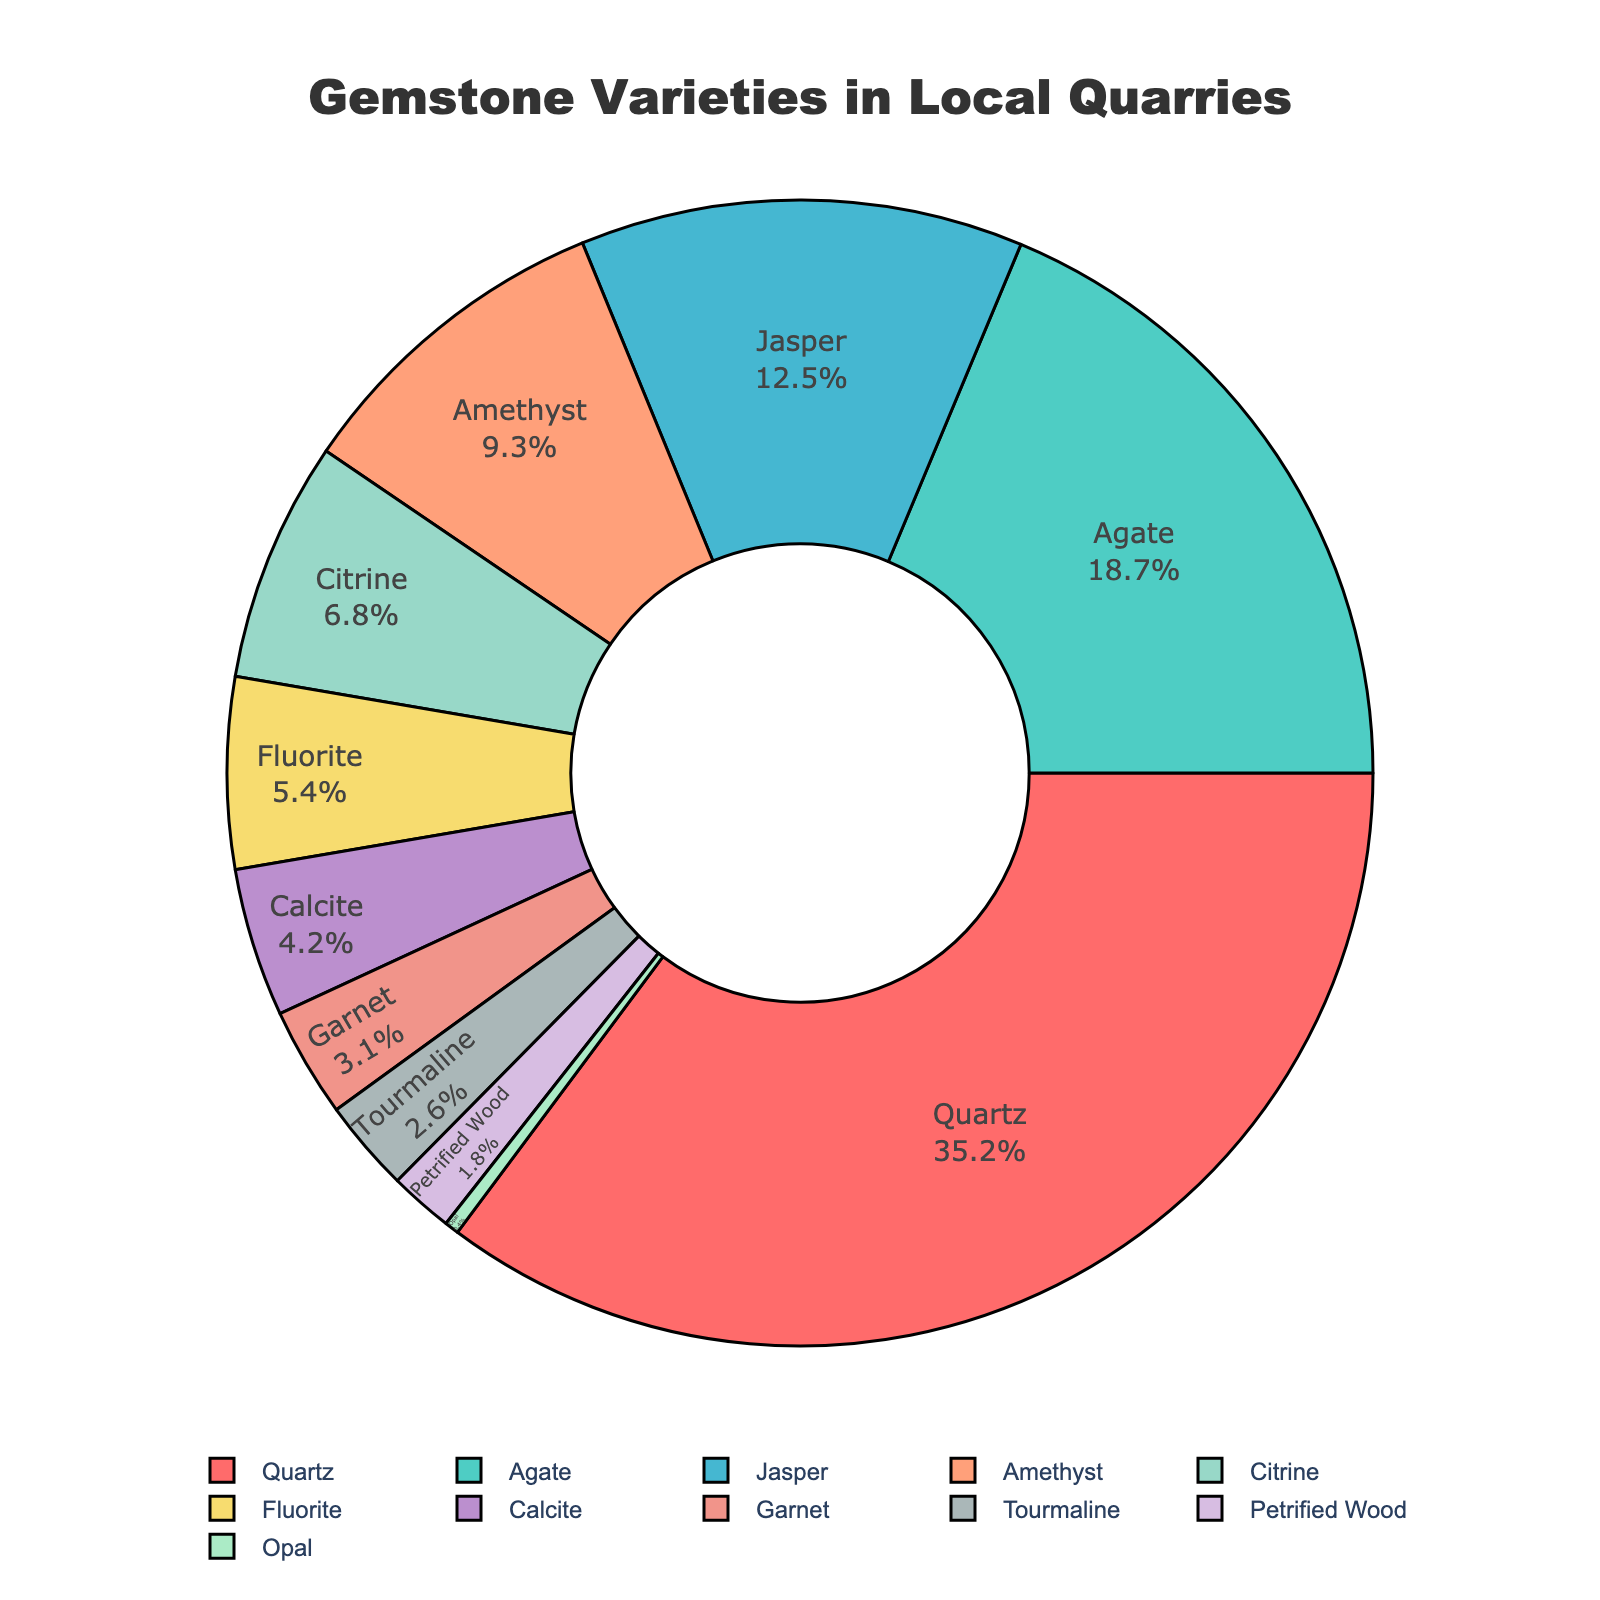what percentage of gemstones found are Quartz and Agate combined? The percentage of Quartz is 35.2% and Agate is 18.7%. Summing these values gives 35.2 + 18.7 = 53.9%.
Answer: 53.9% Which gemstone variety has the smallest percentage? Reviewing the figure, we see that Opal has the smallest percentage at 0.4%.
Answer: Opal How does the percentage of Amethyst compare to Citrine? Amethyst has a percentage of 9.3%, while Citrine has a percentage of 6.8%. Therefore, Amethyst is larger than Citrine.
Answer: Amethyst is larger What is the total percentage of Jasper, Fluorite, and Calcite? The percentages are Jasper 12.5%, Fluorite 5.4%, and Calcite 4.2%. Adding these gives 12.5 + 5.4 + 4.2 = 22.1%.
Answer: 22.1% What is the percentage difference between the highest and the lowest gemstone variety? Quartz has the highest percentage at 35.2% and Opal has the lowest at 0.4%. The difference is 35.2 - 0.4 = 34.8%.
Answer: 34.8% Which gemstone variety is indicated by the yellow color in the pie chart? Observing the pie chart, the yellow color represents Citrine, which has a 6.8% share.
Answer: Citrine What percentage of gemstones collected fall under the categories of Garnet and Tourmaline? Garnet is 3.1% and Tourmaline is 2.6%, summing these gives 3.1 + 2.6 = 5.7%.
Answer: 5.7% Are there more varieties with percentages above or below 10%? The varieties above 10% are Quartz (35.2%), Agate (18.7%), and Jasper (12.5%). The varieties below 10% are Amethyst, Citrine, Fluorite, Calcite, Garnet, Tourmaline, Petrified Wood, and Opal. Thus, there are 7 varieties below 10% and 3 above, indicating more varieties are below 10%.
Answer: Below 10% What is the percentage of all gemstone varieties other than Quartz? Subtract the percentage of Quartz from 100%, which is 100% - 35.2% = 64.8%.
Answer: 64.8% Is the sum of the percentage of Fluorite, Calcite, and Garnet more than 10%? Fluorite has 5.4%, Calcite has 4.2%, and Garnet has 3.1%. Adding these gives 5.4 + 4.2 + 3.1 = 12.7%, which is more than 10%.
Answer: Yes 